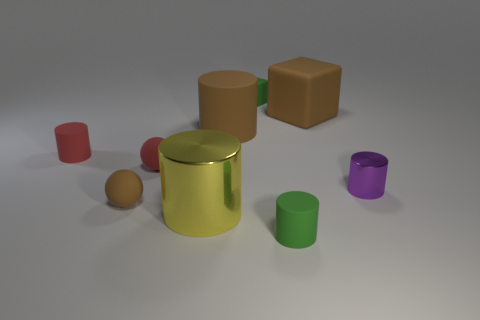The other large shiny thing that is the same shape as the purple shiny object is what color?
Offer a very short reply. Yellow. The small purple cylinder that is to the right of the red rubber thing that is to the right of the tiny red matte cylinder is made of what material?
Provide a short and direct response. Metal. Does the tiny green thing that is behind the small red rubber sphere have the same shape as the big yellow object in front of the small matte cube?
Offer a very short reply. No. There is a cylinder that is both left of the green block and in front of the small brown matte object; how big is it?
Offer a terse response. Large. How many other things are there of the same color as the large metallic cylinder?
Your answer should be very brief. 0. Does the cylinder right of the big rubber cube have the same material as the small red cylinder?
Offer a terse response. No. Is there any other thing that has the same size as the brown ball?
Provide a short and direct response. Yes. Are there fewer large blocks that are in front of the small purple metal cylinder than yellow cylinders right of the large shiny cylinder?
Ensure brevity in your answer.  No. Is there any other thing that has the same shape as the purple thing?
Ensure brevity in your answer.  Yes. What material is the large thing that is the same color as the big rubber block?
Offer a very short reply. Rubber. 